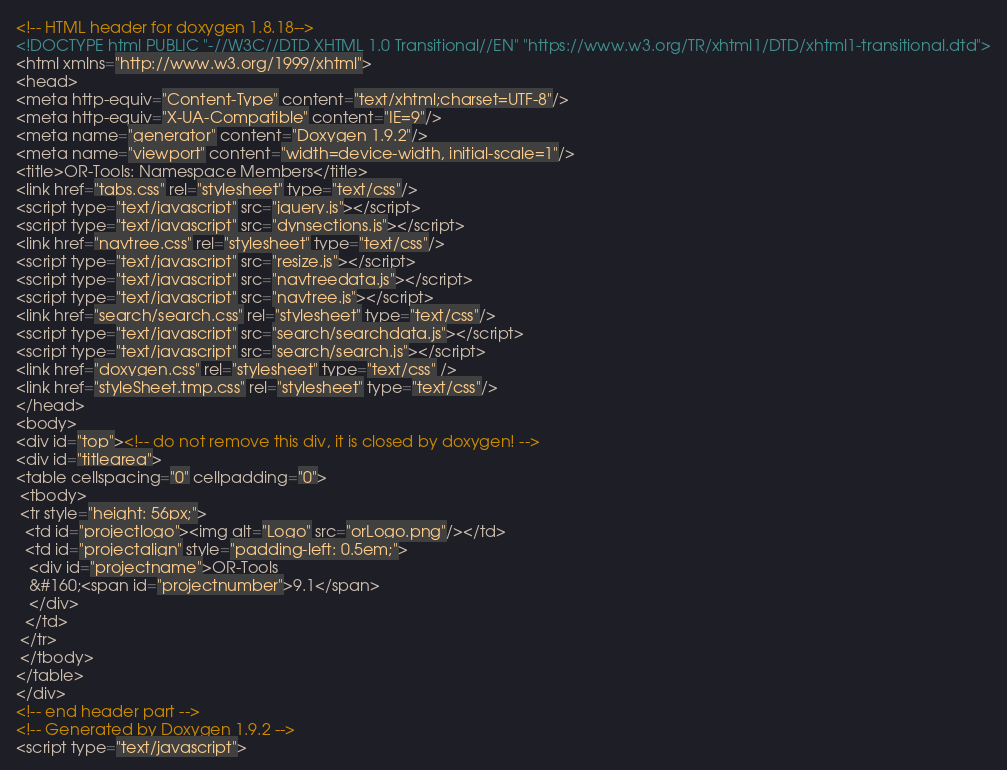<code> <loc_0><loc_0><loc_500><loc_500><_HTML_><!-- HTML header for doxygen 1.8.18-->
<!DOCTYPE html PUBLIC "-//W3C//DTD XHTML 1.0 Transitional//EN" "https://www.w3.org/TR/xhtml1/DTD/xhtml1-transitional.dtd">
<html xmlns="http://www.w3.org/1999/xhtml">
<head>
<meta http-equiv="Content-Type" content="text/xhtml;charset=UTF-8"/>
<meta http-equiv="X-UA-Compatible" content="IE=9"/>
<meta name="generator" content="Doxygen 1.9.2"/>
<meta name="viewport" content="width=device-width, initial-scale=1"/>
<title>OR-Tools: Namespace Members</title>
<link href="tabs.css" rel="stylesheet" type="text/css"/>
<script type="text/javascript" src="jquery.js"></script>
<script type="text/javascript" src="dynsections.js"></script>
<link href="navtree.css" rel="stylesheet" type="text/css"/>
<script type="text/javascript" src="resize.js"></script>
<script type="text/javascript" src="navtreedata.js"></script>
<script type="text/javascript" src="navtree.js"></script>
<link href="search/search.css" rel="stylesheet" type="text/css"/>
<script type="text/javascript" src="search/searchdata.js"></script>
<script type="text/javascript" src="search/search.js"></script>
<link href="doxygen.css" rel="stylesheet" type="text/css" />
<link href="styleSheet.tmp.css" rel="stylesheet" type="text/css"/>
</head>
<body>
<div id="top"><!-- do not remove this div, it is closed by doxygen! -->
<div id="titlearea">
<table cellspacing="0" cellpadding="0">
 <tbody>
 <tr style="height: 56px;">
  <td id="projectlogo"><img alt="Logo" src="orLogo.png"/></td>
  <td id="projectalign" style="padding-left: 0.5em;">
   <div id="projectname">OR-Tools
   &#160;<span id="projectnumber">9.1</span>
   </div>
  </td>
 </tr>
 </tbody>
</table>
</div>
<!-- end header part -->
<!-- Generated by Doxygen 1.9.2 -->
<script type="text/javascript"></code> 